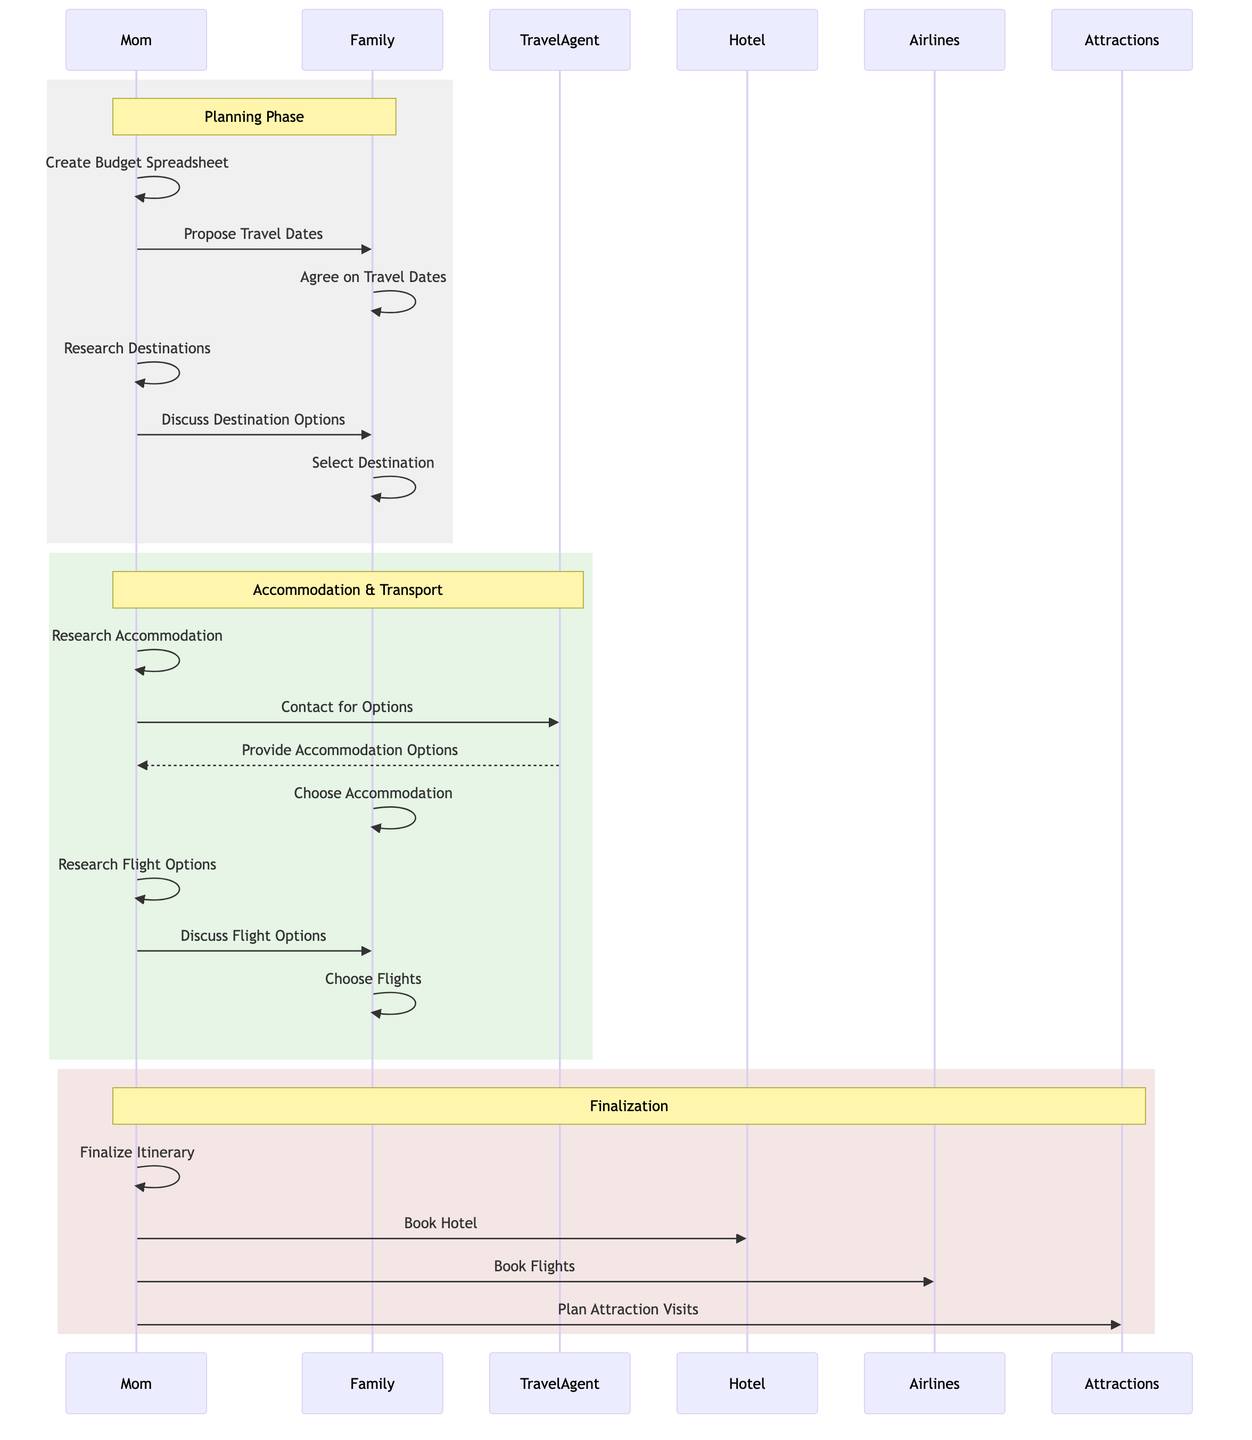What is the first action in the planning phase? The first action in the planning phase is initiated by Mom, who creates the Family Budget Spreadsheet. This is evidenced by the first interaction in the first rectangular section of the diagram.
Answer: Create Budget Spreadsheet How many actors are involved in the sequence? The sequence diagram lists a total of eight actors: Mom, Dad, Oldest Child, Spouse, Travel Agent, Hotel, Airlines, and Attractions. Each actor is involved in various actions throughout the process.
Answer: Eight Who does Mom contact for accommodation options? Mom contacts the Travel Agent for accommodation options, as shown in the second rectangular section of the diagram where this action is explicitly directed to the Travel Agent.
Answer: Travel Agent What is the last action Mom takes? The last action taken by Mom is to plan attraction visits, which is the final action listed in the third rectangular section of the diagram, indicating the conclusion of the vacation planning process.
Answer: Plan Attraction Visits Which actor finalizes the itinerary? It is Mom who finalizes the itinerary, as illustrated in the third section of the sequence where her action for finalizing the itinerary appears before booking the hotel and flights.
Answer: Mom How many actions are performed by Mom in the entire sequence? Mom performs a total of seven distinct actions throughout the sequence, which includes creating the budget, proposing dates, researching destinations, and facilitating bookings, among others.
Answer: Seven What phase involves discussing flight options with the family? The phase that involves discussing flight options with the family is specifically labeled as "Accommodation & Transport" in the second rectangular section of the diagram, where the action takes place after researching flight options.
Answer: Accommodation & Transport Who provides accommodation options? The Travel Agent provides accommodation options, indicated by the arrow from the Travel Agent to Mom, showing the communication flow regarding accommodation choices.
Answer: Travel Agent 